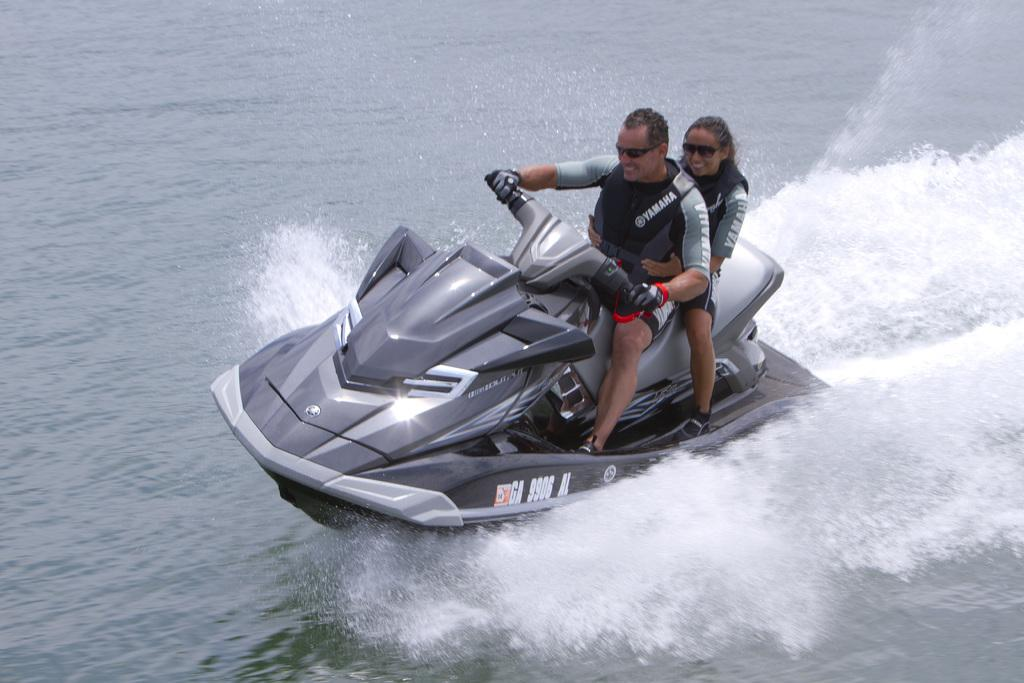Who is present in the image? There is a man and a woman in the image. What are they wearing? Both the man and woman are wearing goggles. What activity are they engaged in? They are jet skiing. What can be seen in the background of the image? There is water visible in the image. What industry is represented by the hands of the man in the image? There are no hands visible in the image, and no industry is represented. 